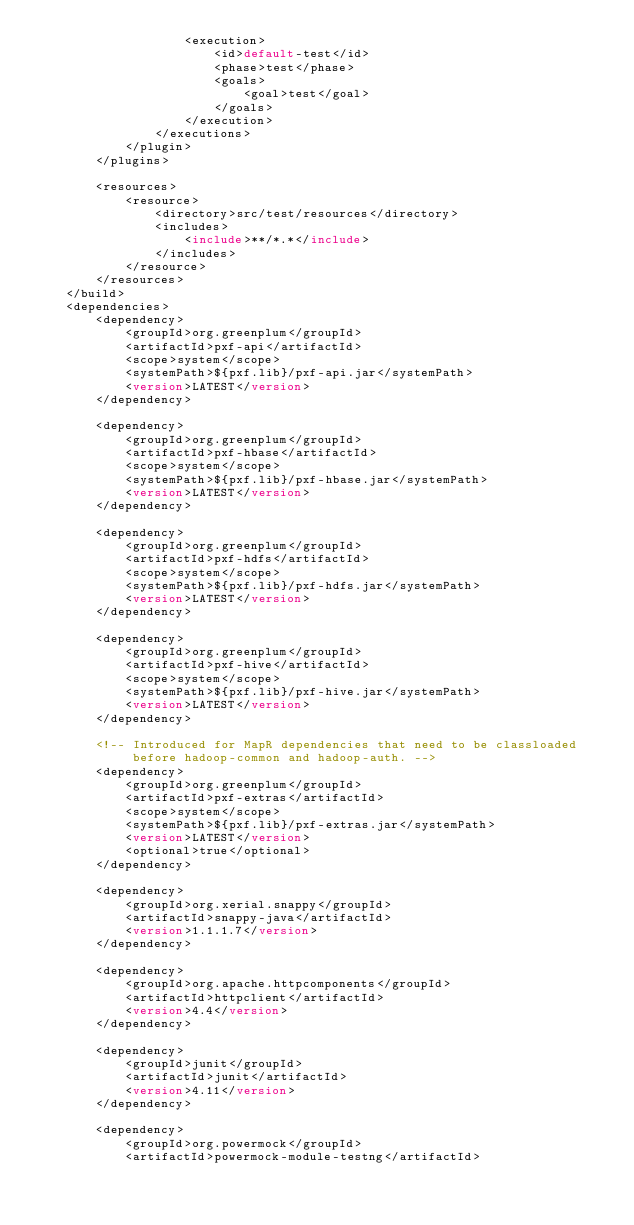<code> <loc_0><loc_0><loc_500><loc_500><_XML_>                    <execution>
                        <id>default-test</id>
                        <phase>test</phase>
                        <goals>
                            <goal>test</goal>
                        </goals>
                    </execution>
                </executions>
            </plugin>
        </plugins>

        <resources>
            <resource>
                <directory>src/test/resources</directory>
                <includes>
                    <include>**/*.*</include>
                </includes>
            </resource>
        </resources>
    </build>
    <dependencies>
        <dependency>
            <groupId>org.greenplum</groupId>
            <artifactId>pxf-api</artifactId>
            <scope>system</scope>
            <systemPath>${pxf.lib}/pxf-api.jar</systemPath>
            <version>LATEST</version>
        </dependency>

        <dependency>
            <groupId>org.greenplum</groupId>
            <artifactId>pxf-hbase</artifactId>
            <scope>system</scope>
            <systemPath>${pxf.lib}/pxf-hbase.jar</systemPath>
            <version>LATEST</version>
        </dependency>

        <dependency>
            <groupId>org.greenplum</groupId>
            <artifactId>pxf-hdfs</artifactId>
            <scope>system</scope>
            <systemPath>${pxf.lib}/pxf-hdfs.jar</systemPath>
            <version>LATEST</version>
        </dependency>

        <dependency>
            <groupId>org.greenplum</groupId>
            <artifactId>pxf-hive</artifactId>
            <scope>system</scope>
            <systemPath>${pxf.lib}/pxf-hive.jar</systemPath>
            <version>LATEST</version>
        </dependency>

        <!-- Introduced for MapR dependencies that need to be classloaded
             before hadoop-common and hadoop-auth. -->
        <dependency>
            <groupId>org.greenplum</groupId>
            <artifactId>pxf-extras</artifactId>
            <scope>system</scope>
            <systemPath>${pxf.lib}/pxf-extras.jar</systemPath>
            <version>LATEST</version>
            <optional>true</optional>
        </dependency>

        <dependency>
            <groupId>org.xerial.snappy</groupId>
            <artifactId>snappy-java</artifactId>
            <version>1.1.1.7</version>
        </dependency>

        <dependency>
            <groupId>org.apache.httpcomponents</groupId>
            <artifactId>httpclient</artifactId>
            <version>4.4</version>
        </dependency>

        <dependency>
            <groupId>junit</groupId>
            <artifactId>junit</artifactId>
            <version>4.11</version>
        </dependency>

        <dependency>
            <groupId>org.powermock</groupId>
            <artifactId>powermock-module-testng</artifactId></code> 